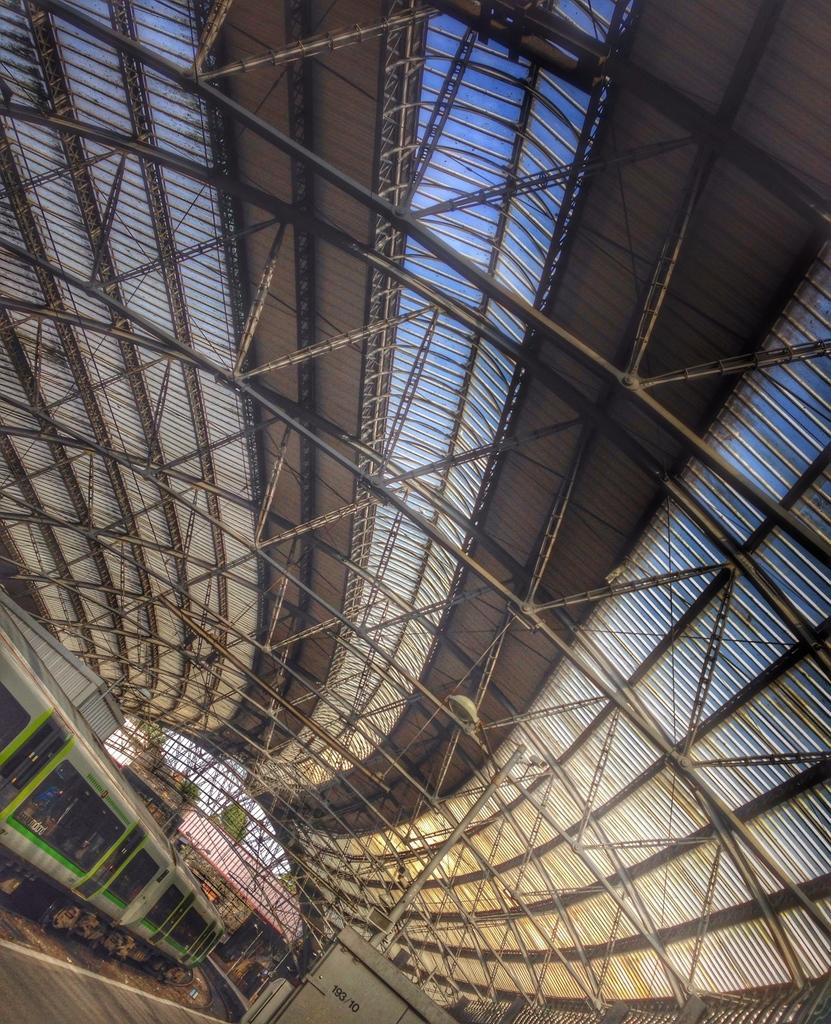What is the main subject of the image? The main subject of the image is a train. Where is the train located in the image? The train is on a railway track. What material covers the roof of the train? The roof of the train is covered with asbestos sheets. What other structural elements can be seen on the roof of the train? Iron rods are present on the roof of the train. What type of behavior is exhibited by the rose in the image? There is no rose present in the image; it features a train on a railway track. 